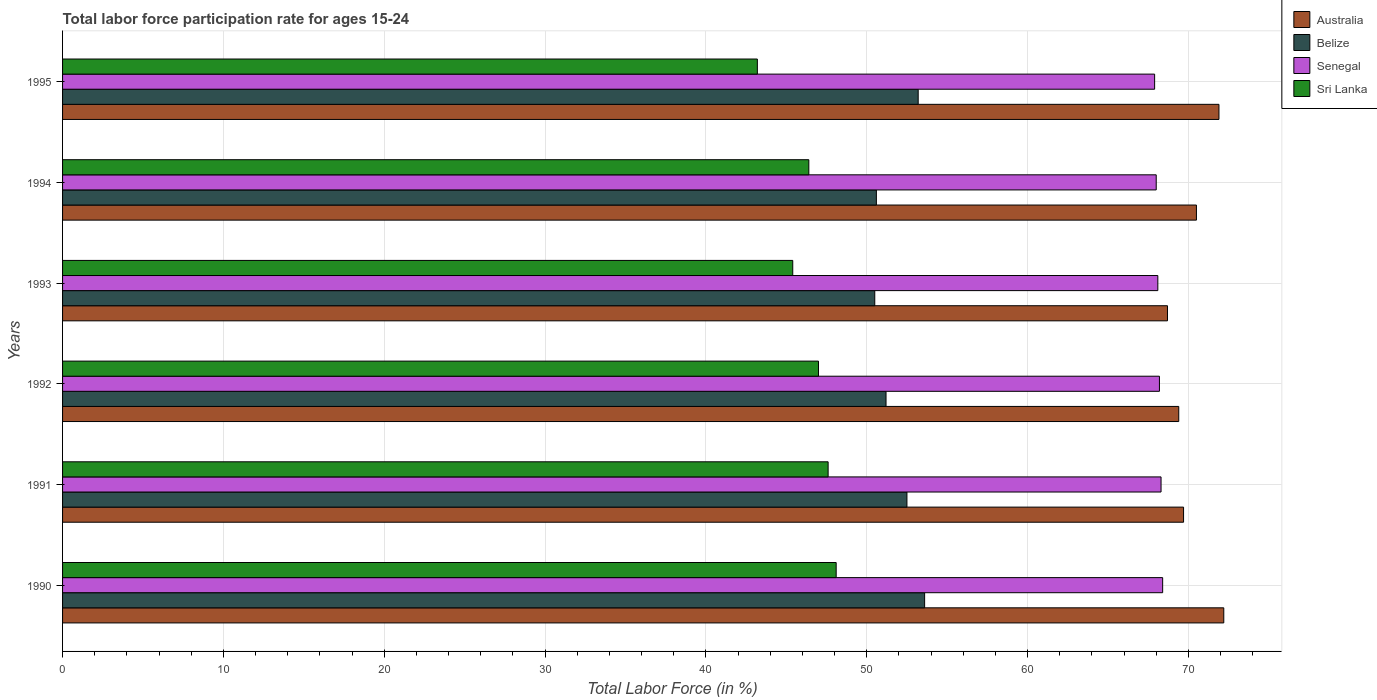How many different coloured bars are there?
Provide a succinct answer. 4. How many groups of bars are there?
Offer a terse response. 6. Are the number of bars per tick equal to the number of legend labels?
Offer a very short reply. Yes. Are the number of bars on each tick of the Y-axis equal?
Your answer should be very brief. Yes. How many bars are there on the 5th tick from the top?
Offer a very short reply. 4. How many bars are there on the 4th tick from the bottom?
Your answer should be very brief. 4. In how many cases, is the number of bars for a given year not equal to the number of legend labels?
Give a very brief answer. 0. What is the labor force participation rate in Sri Lanka in 1993?
Provide a short and direct response. 45.4. Across all years, what is the maximum labor force participation rate in Belize?
Provide a short and direct response. 53.6. Across all years, what is the minimum labor force participation rate in Belize?
Make the answer very short. 50.5. In which year was the labor force participation rate in Belize maximum?
Your answer should be compact. 1990. In which year was the labor force participation rate in Sri Lanka minimum?
Your response must be concise. 1995. What is the total labor force participation rate in Senegal in the graph?
Keep it short and to the point. 408.9. What is the difference between the labor force participation rate in Belize in 1994 and that in 1995?
Provide a succinct answer. -2.6. What is the difference between the labor force participation rate in Sri Lanka in 1992 and the labor force participation rate in Senegal in 1995?
Your response must be concise. -20.9. What is the average labor force participation rate in Sri Lanka per year?
Ensure brevity in your answer.  46.28. In the year 1993, what is the difference between the labor force participation rate in Australia and labor force participation rate in Belize?
Ensure brevity in your answer.  18.2. What is the ratio of the labor force participation rate in Australia in 1994 to that in 1995?
Offer a very short reply. 0.98. Is the difference between the labor force participation rate in Australia in 1990 and 1993 greater than the difference between the labor force participation rate in Belize in 1990 and 1993?
Your answer should be very brief. Yes. What is the difference between the highest and the second highest labor force participation rate in Belize?
Ensure brevity in your answer.  0.4. What is the difference between the highest and the lowest labor force participation rate in Belize?
Your answer should be very brief. 3.1. Is the sum of the labor force participation rate in Australia in 1990 and 1995 greater than the maximum labor force participation rate in Belize across all years?
Make the answer very short. Yes. Is it the case that in every year, the sum of the labor force participation rate in Belize and labor force participation rate in Senegal is greater than the sum of labor force participation rate in Sri Lanka and labor force participation rate in Australia?
Provide a short and direct response. Yes. What does the 1st bar from the top in 1992 represents?
Make the answer very short. Sri Lanka. What does the 2nd bar from the bottom in 1994 represents?
Your answer should be very brief. Belize. Is it the case that in every year, the sum of the labor force participation rate in Belize and labor force participation rate in Senegal is greater than the labor force participation rate in Australia?
Keep it short and to the point. Yes. Does the graph contain any zero values?
Ensure brevity in your answer.  No. Does the graph contain grids?
Give a very brief answer. Yes. How many legend labels are there?
Offer a very short reply. 4. What is the title of the graph?
Offer a very short reply. Total labor force participation rate for ages 15-24. Does "Upper middle income" appear as one of the legend labels in the graph?
Make the answer very short. No. What is the Total Labor Force (in %) in Australia in 1990?
Your response must be concise. 72.2. What is the Total Labor Force (in %) of Belize in 1990?
Give a very brief answer. 53.6. What is the Total Labor Force (in %) in Senegal in 1990?
Ensure brevity in your answer.  68.4. What is the Total Labor Force (in %) of Sri Lanka in 1990?
Ensure brevity in your answer.  48.1. What is the Total Labor Force (in %) in Australia in 1991?
Your answer should be very brief. 69.7. What is the Total Labor Force (in %) in Belize in 1991?
Offer a very short reply. 52.5. What is the Total Labor Force (in %) of Senegal in 1991?
Offer a very short reply. 68.3. What is the Total Labor Force (in %) in Sri Lanka in 1991?
Make the answer very short. 47.6. What is the Total Labor Force (in %) of Australia in 1992?
Your answer should be very brief. 69.4. What is the Total Labor Force (in %) in Belize in 1992?
Your answer should be very brief. 51.2. What is the Total Labor Force (in %) in Senegal in 1992?
Give a very brief answer. 68.2. What is the Total Labor Force (in %) in Australia in 1993?
Your answer should be very brief. 68.7. What is the Total Labor Force (in %) in Belize in 1993?
Offer a terse response. 50.5. What is the Total Labor Force (in %) of Senegal in 1993?
Provide a succinct answer. 68.1. What is the Total Labor Force (in %) of Sri Lanka in 1993?
Provide a succinct answer. 45.4. What is the Total Labor Force (in %) of Australia in 1994?
Offer a terse response. 70.5. What is the Total Labor Force (in %) of Belize in 1994?
Offer a terse response. 50.6. What is the Total Labor Force (in %) of Senegal in 1994?
Your answer should be compact. 68. What is the Total Labor Force (in %) in Sri Lanka in 1994?
Make the answer very short. 46.4. What is the Total Labor Force (in %) of Australia in 1995?
Offer a terse response. 71.9. What is the Total Labor Force (in %) of Belize in 1995?
Provide a short and direct response. 53.2. What is the Total Labor Force (in %) in Senegal in 1995?
Offer a terse response. 67.9. What is the Total Labor Force (in %) in Sri Lanka in 1995?
Your answer should be compact. 43.2. Across all years, what is the maximum Total Labor Force (in %) in Australia?
Offer a terse response. 72.2. Across all years, what is the maximum Total Labor Force (in %) in Belize?
Offer a very short reply. 53.6. Across all years, what is the maximum Total Labor Force (in %) in Senegal?
Keep it short and to the point. 68.4. Across all years, what is the maximum Total Labor Force (in %) in Sri Lanka?
Offer a terse response. 48.1. Across all years, what is the minimum Total Labor Force (in %) in Australia?
Ensure brevity in your answer.  68.7. Across all years, what is the minimum Total Labor Force (in %) of Belize?
Provide a succinct answer. 50.5. Across all years, what is the minimum Total Labor Force (in %) in Senegal?
Offer a terse response. 67.9. Across all years, what is the minimum Total Labor Force (in %) of Sri Lanka?
Your answer should be compact. 43.2. What is the total Total Labor Force (in %) of Australia in the graph?
Provide a short and direct response. 422.4. What is the total Total Labor Force (in %) of Belize in the graph?
Offer a terse response. 311.6. What is the total Total Labor Force (in %) in Senegal in the graph?
Provide a short and direct response. 408.9. What is the total Total Labor Force (in %) of Sri Lanka in the graph?
Provide a short and direct response. 277.7. What is the difference between the Total Labor Force (in %) in Belize in 1990 and that in 1991?
Offer a very short reply. 1.1. What is the difference between the Total Labor Force (in %) in Senegal in 1990 and that in 1991?
Offer a terse response. 0.1. What is the difference between the Total Labor Force (in %) in Sri Lanka in 1990 and that in 1991?
Offer a very short reply. 0.5. What is the difference between the Total Labor Force (in %) in Australia in 1990 and that in 1992?
Your answer should be compact. 2.8. What is the difference between the Total Labor Force (in %) in Australia in 1990 and that in 1993?
Your answer should be very brief. 3.5. What is the difference between the Total Labor Force (in %) in Belize in 1990 and that in 1994?
Your answer should be very brief. 3. What is the difference between the Total Labor Force (in %) of Senegal in 1990 and that in 1995?
Offer a terse response. 0.5. What is the difference between the Total Labor Force (in %) of Australia in 1991 and that in 1992?
Your response must be concise. 0.3. What is the difference between the Total Labor Force (in %) of Belize in 1991 and that in 1992?
Offer a terse response. 1.3. What is the difference between the Total Labor Force (in %) in Senegal in 1991 and that in 1992?
Provide a short and direct response. 0.1. What is the difference between the Total Labor Force (in %) of Australia in 1991 and that in 1993?
Your answer should be very brief. 1. What is the difference between the Total Labor Force (in %) of Senegal in 1991 and that in 1993?
Your answer should be compact. 0.2. What is the difference between the Total Labor Force (in %) of Australia in 1991 and that in 1994?
Provide a succinct answer. -0.8. What is the difference between the Total Labor Force (in %) in Belize in 1991 and that in 1995?
Offer a very short reply. -0.7. What is the difference between the Total Labor Force (in %) of Sri Lanka in 1991 and that in 1995?
Provide a short and direct response. 4.4. What is the difference between the Total Labor Force (in %) in Belize in 1992 and that in 1993?
Offer a very short reply. 0.7. What is the difference between the Total Labor Force (in %) of Australia in 1992 and that in 1994?
Your answer should be compact. -1.1. What is the difference between the Total Labor Force (in %) in Senegal in 1992 and that in 1994?
Your answer should be compact. 0.2. What is the difference between the Total Labor Force (in %) in Belize in 1992 and that in 1995?
Your response must be concise. -2. What is the difference between the Total Labor Force (in %) of Sri Lanka in 1992 and that in 1995?
Make the answer very short. 3.8. What is the difference between the Total Labor Force (in %) of Belize in 1993 and that in 1994?
Offer a very short reply. -0.1. What is the difference between the Total Labor Force (in %) of Senegal in 1993 and that in 1994?
Make the answer very short. 0.1. What is the difference between the Total Labor Force (in %) in Sri Lanka in 1993 and that in 1994?
Keep it short and to the point. -1. What is the difference between the Total Labor Force (in %) of Belize in 1993 and that in 1995?
Keep it short and to the point. -2.7. What is the difference between the Total Labor Force (in %) of Senegal in 1993 and that in 1995?
Your answer should be compact. 0.2. What is the difference between the Total Labor Force (in %) of Australia in 1994 and that in 1995?
Offer a very short reply. -1.4. What is the difference between the Total Labor Force (in %) in Belize in 1994 and that in 1995?
Provide a succinct answer. -2.6. What is the difference between the Total Labor Force (in %) in Senegal in 1994 and that in 1995?
Your answer should be very brief. 0.1. What is the difference between the Total Labor Force (in %) of Sri Lanka in 1994 and that in 1995?
Your answer should be compact. 3.2. What is the difference between the Total Labor Force (in %) in Australia in 1990 and the Total Labor Force (in %) in Belize in 1991?
Offer a terse response. 19.7. What is the difference between the Total Labor Force (in %) of Australia in 1990 and the Total Labor Force (in %) of Senegal in 1991?
Your answer should be compact. 3.9. What is the difference between the Total Labor Force (in %) of Australia in 1990 and the Total Labor Force (in %) of Sri Lanka in 1991?
Give a very brief answer. 24.6. What is the difference between the Total Labor Force (in %) in Belize in 1990 and the Total Labor Force (in %) in Senegal in 1991?
Ensure brevity in your answer.  -14.7. What is the difference between the Total Labor Force (in %) of Belize in 1990 and the Total Labor Force (in %) of Sri Lanka in 1991?
Your answer should be very brief. 6. What is the difference between the Total Labor Force (in %) in Senegal in 1990 and the Total Labor Force (in %) in Sri Lanka in 1991?
Make the answer very short. 20.8. What is the difference between the Total Labor Force (in %) in Australia in 1990 and the Total Labor Force (in %) in Belize in 1992?
Provide a succinct answer. 21. What is the difference between the Total Labor Force (in %) in Australia in 1990 and the Total Labor Force (in %) in Senegal in 1992?
Keep it short and to the point. 4. What is the difference between the Total Labor Force (in %) in Australia in 1990 and the Total Labor Force (in %) in Sri Lanka in 1992?
Offer a very short reply. 25.2. What is the difference between the Total Labor Force (in %) in Belize in 1990 and the Total Labor Force (in %) in Senegal in 1992?
Your answer should be very brief. -14.6. What is the difference between the Total Labor Force (in %) in Belize in 1990 and the Total Labor Force (in %) in Sri Lanka in 1992?
Make the answer very short. 6.6. What is the difference between the Total Labor Force (in %) in Senegal in 1990 and the Total Labor Force (in %) in Sri Lanka in 1992?
Provide a short and direct response. 21.4. What is the difference between the Total Labor Force (in %) of Australia in 1990 and the Total Labor Force (in %) of Belize in 1993?
Your answer should be compact. 21.7. What is the difference between the Total Labor Force (in %) in Australia in 1990 and the Total Labor Force (in %) in Sri Lanka in 1993?
Your answer should be compact. 26.8. What is the difference between the Total Labor Force (in %) of Belize in 1990 and the Total Labor Force (in %) of Senegal in 1993?
Your answer should be very brief. -14.5. What is the difference between the Total Labor Force (in %) in Australia in 1990 and the Total Labor Force (in %) in Belize in 1994?
Offer a very short reply. 21.6. What is the difference between the Total Labor Force (in %) in Australia in 1990 and the Total Labor Force (in %) in Sri Lanka in 1994?
Provide a succinct answer. 25.8. What is the difference between the Total Labor Force (in %) of Belize in 1990 and the Total Labor Force (in %) of Senegal in 1994?
Offer a very short reply. -14.4. What is the difference between the Total Labor Force (in %) in Senegal in 1990 and the Total Labor Force (in %) in Sri Lanka in 1994?
Your response must be concise. 22. What is the difference between the Total Labor Force (in %) of Belize in 1990 and the Total Labor Force (in %) of Senegal in 1995?
Provide a succinct answer. -14.3. What is the difference between the Total Labor Force (in %) of Belize in 1990 and the Total Labor Force (in %) of Sri Lanka in 1995?
Your answer should be compact. 10.4. What is the difference between the Total Labor Force (in %) in Senegal in 1990 and the Total Labor Force (in %) in Sri Lanka in 1995?
Give a very brief answer. 25.2. What is the difference between the Total Labor Force (in %) of Australia in 1991 and the Total Labor Force (in %) of Belize in 1992?
Ensure brevity in your answer.  18.5. What is the difference between the Total Labor Force (in %) of Australia in 1991 and the Total Labor Force (in %) of Senegal in 1992?
Give a very brief answer. 1.5. What is the difference between the Total Labor Force (in %) of Australia in 1991 and the Total Labor Force (in %) of Sri Lanka in 1992?
Ensure brevity in your answer.  22.7. What is the difference between the Total Labor Force (in %) of Belize in 1991 and the Total Labor Force (in %) of Senegal in 1992?
Provide a short and direct response. -15.7. What is the difference between the Total Labor Force (in %) in Belize in 1991 and the Total Labor Force (in %) in Sri Lanka in 1992?
Provide a short and direct response. 5.5. What is the difference between the Total Labor Force (in %) in Senegal in 1991 and the Total Labor Force (in %) in Sri Lanka in 1992?
Make the answer very short. 21.3. What is the difference between the Total Labor Force (in %) of Australia in 1991 and the Total Labor Force (in %) of Senegal in 1993?
Provide a succinct answer. 1.6. What is the difference between the Total Labor Force (in %) of Australia in 1991 and the Total Labor Force (in %) of Sri Lanka in 1993?
Your answer should be very brief. 24.3. What is the difference between the Total Labor Force (in %) in Belize in 1991 and the Total Labor Force (in %) in Senegal in 1993?
Offer a terse response. -15.6. What is the difference between the Total Labor Force (in %) in Belize in 1991 and the Total Labor Force (in %) in Sri Lanka in 1993?
Keep it short and to the point. 7.1. What is the difference between the Total Labor Force (in %) of Senegal in 1991 and the Total Labor Force (in %) of Sri Lanka in 1993?
Your answer should be compact. 22.9. What is the difference between the Total Labor Force (in %) of Australia in 1991 and the Total Labor Force (in %) of Belize in 1994?
Offer a terse response. 19.1. What is the difference between the Total Labor Force (in %) of Australia in 1991 and the Total Labor Force (in %) of Senegal in 1994?
Your answer should be compact. 1.7. What is the difference between the Total Labor Force (in %) of Australia in 1991 and the Total Labor Force (in %) of Sri Lanka in 1994?
Offer a terse response. 23.3. What is the difference between the Total Labor Force (in %) of Belize in 1991 and the Total Labor Force (in %) of Senegal in 1994?
Provide a succinct answer. -15.5. What is the difference between the Total Labor Force (in %) of Belize in 1991 and the Total Labor Force (in %) of Sri Lanka in 1994?
Offer a terse response. 6.1. What is the difference between the Total Labor Force (in %) in Senegal in 1991 and the Total Labor Force (in %) in Sri Lanka in 1994?
Offer a terse response. 21.9. What is the difference between the Total Labor Force (in %) of Australia in 1991 and the Total Labor Force (in %) of Sri Lanka in 1995?
Your answer should be compact. 26.5. What is the difference between the Total Labor Force (in %) of Belize in 1991 and the Total Labor Force (in %) of Senegal in 1995?
Your answer should be compact. -15.4. What is the difference between the Total Labor Force (in %) in Senegal in 1991 and the Total Labor Force (in %) in Sri Lanka in 1995?
Your answer should be compact. 25.1. What is the difference between the Total Labor Force (in %) of Australia in 1992 and the Total Labor Force (in %) of Senegal in 1993?
Make the answer very short. 1.3. What is the difference between the Total Labor Force (in %) in Australia in 1992 and the Total Labor Force (in %) in Sri Lanka in 1993?
Keep it short and to the point. 24. What is the difference between the Total Labor Force (in %) of Belize in 1992 and the Total Labor Force (in %) of Senegal in 1993?
Ensure brevity in your answer.  -16.9. What is the difference between the Total Labor Force (in %) of Belize in 1992 and the Total Labor Force (in %) of Sri Lanka in 1993?
Your answer should be compact. 5.8. What is the difference between the Total Labor Force (in %) in Senegal in 1992 and the Total Labor Force (in %) in Sri Lanka in 1993?
Ensure brevity in your answer.  22.8. What is the difference between the Total Labor Force (in %) of Australia in 1992 and the Total Labor Force (in %) of Sri Lanka in 1994?
Provide a succinct answer. 23. What is the difference between the Total Labor Force (in %) in Belize in 1992 and the Total Labor Force (in %) in Senegal in 1994?
Give a very brief answer. -16.8. What is the difference between the Total Labor Force (in %) in Belize in 1992 and the Total Labor Force (in %) in Sri Lanka in 1994?
Make the answer very short. 4.8. What is the difference between the Total Labor Force (in %) in Senegal in 1992 and the Total Labor Force (in %) in Sri Lanka in 1994?
Offer a terse response. 21.8. What is the difference between the Total Labor Force (in %) of Australia in 1992 and the Total Labor Force (in %) of Sri Lanka in 1995?
Your response must be concise. 26.2. What is the difference between the Total Labor Force (in %) in Belize in 1992 and the Total Labor Force (in %) in Senegal in 1995?
Your answer should be very brief. -16.7. What is the difference between the Total Labor Force (in %) in Senegal in 1992 and the Total Labor Force (in %) in Sri Lanka in 1995?
Your answer should be very brief. 25. What is the difference between the Total Labor Force (in %) of Australia in 1993 and the Total Labor Force (in %) of Belize in 1994?
Your response must be concise. 18.1. What is the difference between the Total Labor Force (in %) of Australia in 1993 and the Total Labor Force (in %) of Sri Lanka in 1994?
Provide a short and direct response. 22.3. What is the difference between the Total Labor Force (in %) in Belize in 1993 and the Total Labor Force (in %) in Senegal in 1994?
Your answer should be very brief. -17.5. What is the difference between the Total Labor Force (in %) in Senegal in 1993 and the Total Labor Force (in %) in Sri Lanka in 1994?
Your answer should be compact. 21.7. What is the difference between the Total Labor Force (in %) of Australia in 1993 and the Total Labor Force (in %) of Belize in 1995?
Make the answer very short. 15.5. What is the difference between the Total Labor Force (in %) of Australia in 1993 and the Total Labor Force (in %) of Sri Lanka in 1995?
Your answer should be very brief. 25.5. What is the difference between the Total Labor Force (in %) in Belize in 1993 and the Total Labor Force (in %) in Senegal in 1995?
Your answer should be compact. -17.4. What is the difference between the Total Labor Force (in %) in Belize in 1993 and the Total Labor Force (in %) in Sri Lanka in 1995?
Your response must be concise. 7.3. What is the difference between the Total Labor Force (in %) in Senegal in 1993 and the Total Labor Force (in %) in Sri Lanka in 1995?
Make the answer very short. 24.9. What is the difference between the Total Labor Force (in %) in Australia in 1994 and the Total Labor Force (in %) in Belize in 1995?
Give a very brief answer. 17.3. What is the difference between the Total Labor Force (in %) in Australia in 1994 and the Total Labor Force (in %) in Sri Lanka in 1995?
Ensure brevity in your answer.  27.3. What is the difference between the Total Labor Force (in %) in Belize in 1994 and the Total Labor Force (in %) in Senegal in 1995?
Your answer should be compact. -17.3. What is the difference between the Total Labor Force (in %) of Senegal in 1994 and the Total Labor Force (in %) of Sri Lanka in 1995?
Your answer should be very brief. 24.8. What is the average Total Labor Force (in %) in Australia per year?
Your answer should be compact. 70.4. What is the average Total Labor Force (in %) in Belize per year?
Your answer should be compact. 51.93. What is the average Total Labor Force (in %) of Senegal per year?
Offer a very short reply. 68.15. What is the average Total Labor Force (in %) in Sri Lanka per year?
Offer a very short reply. 46.28. In the year 1990, what is the difference between the Total Labor Force (in %) in Australia and Total Labor Force (in %) in Belize?
Your answer should be compact. 18.6. In the year 1990, what is the difference between the Total Labor Force (in %) of Australia and Total Labor Force (in %) of Sri Lanka?
Your response must be concise. 24.1. In the year 1990, what is the difference between the Total Labor Force (in %) of Belize and Total Labor Force (in %) of Senegal?
Your response must be concise. -14.8. In the year 1990, what is the difference between the Total Labor Force (in %) in Senegal and Total Labor Force (in %) in Sri Lanka?
Offer a terse response. 20.3. In the year 1991, what is the difference between the Total Labor Force (in %) of Australia and Total Labor Force (in %) of Sri Lanka?
Make the answer very short. 22.1. In the year 1991, what is the difference between the Total Labor Force (in %) in Belize and Total Labor Force (in %) in Senegal?
Your answer should be very brief. -15.8. In the year 1991, what is the difference between the Total Labor Force (in %) in Senegal and Total Labor Force (in %) in Sri Lanka?
Provide a short and direct response. 20.7. In the year 1992, what is the difference between the Total Labor Force (in %) in Australia and Total Labor Force (in %) in Belize?
Your response must be concise. 18.2. In the year 1992, what is the difference between the Total Labor Force (in %) of Australia and Total Labor Force (in %) of Sri Lanka?
Give a very brief answer. 22.4. In the year 1992, what is the difference between the Total Labor Force (in %) of Belize and Total Labor Force (in %) of Senegal?
Give a very brief answer. -17. In the year 1992, what is the difference between the Total Labor Force (in %) in Belize and Total Labor Force (in %) in Sri Lanka?
Make the answer very short. 4.2. In the year 1992, what is the difference between the Total Labor Force (in %) of Senegal and Total Labor Force (in %) of Sri Lanka?
Your answer should be very brief. 21.2. In the year 1993, what is the difference between the Total Labor Force (in %) in Australia and Total Labor Force (in %) in Senegal?
Keep it short and to the point. 0.6. In the year 1993, what is the difference between the Total Labor Force (in %) in Australia and Total Labor Force (in %) in Sri Lanka?
Offer a very short reply. 23.3. In the year 1993, what is the difference between the Total Labor Force (in %) in Belize and Total Labor Force (in %) in Senegal?
Keep it short and to the point. -17.6. In the year 1993, what is the difference between the Total Labor Force (in %) of Senegal and Total Labor Force (in %) of Sri Lanka?
Offer a very short reply. 22.7. In the year 1994, what is the difference between the Total Labor Force (in %) of Australia and Total Labor Force (in %) of Belize?
Your answer should be compact. 19.9. In the year 1994, what is the difference between the Total Labor Force (in %) in Australia and Total Labor Force (in %) in Sri Lanka?
Provide a short and direct response. 24.1. In the year 1994, what is the difference between the Total Labor Force (in %) in Belize and Total Labor Force (in %) in Senegal?
Provide a succinct answer. -17.4. In the year 1994, what is the difference between the Total Labor Force (in %) of Belize and Total Labor Force (in %) of Sri Lanka?
Offer a very short reply. 4.2. In the year 1994, what is the difference between the Total Labor Force (in %) in Senegal and Total Labor Force (in %) in Sri Lanka?
Make the answer very short. 21.6. In the year 1995, what is the difference between the Total Labor Force (in %) of Australia and Total Labor Force (in %) of Belize?
Your answer should be very brief. 18.7. In the year 1995, what is the difference between the Total Labor Force (in %) in Australia and Total Labor Force (in %) in Senegal?
Offer a terse response. 4. In the year 1995, what is the difference between the Total Labor Force (in %) in Australia and Total Labor Force (in %) in Sri Lanka?
Offer a terse response. 28.7. In the year 1995, what is the difference between the Total Labor Force (in %) in Belize and Total Labor Force (in %) in Senegal?
Ensure brevity in your answer.  -14.7. In the year 1995, what is the difference between the Total Labor Force (in %) of Belize and Total Labor Force (in %) of Sri Lanka?
Offer a very short reply. 10. In the year 1995, what is the difference between the Total Labor Force (in %) in Senegal and Total Labor Force (in %) in Sri Lanka?
Make the answer very short. 24.7. What is the ratio of the Total Labor Force (in %) of Australia in 1990 to that in 1991?
Your response must be concise. 1.04. What is the ratio of the Total Labor Force (in %) in Belize in 1990 to that in 1991?
Your answer should be very brief. 1.02. What is the ratio of the Total Labor Force (in %) of Senegal in 1990 to that in 1991?
Provide a short and direct response. 1. What is the ratio of the Total Labor Force (in %) of Sri Lanka in 1990 to that in 1991?
Offer a terse response. 1.01. What is the ratio of the Total Labor Force (in %) of Australia in 1990 to that in 1992?
Your response must be concise. 1.04. What is the ratio of the Total Labor Force (in %) of Belize in 1990 to that in 1992?
Give a very brief answer. 1.05. What is the ratio of the Total Labor Force (in %) of Sri Lanka in 1990 to that in 1992?
Make the answer very short. 1.02. What is the ratio of the Total Labor Force (in %) in Australia in 1990 to that in 1993?
Your response must be concise. 1.05. What is the ratio of the Total Labor Force (in %) in Belize in 1990 to that in 1993?
Offer a very short reply. 1.06. What is the ratio of the Total Labor Force (in %) of Sri Lanka in 1990 to that in 1993?
Your answer should be very brief. 1.06. What is the ratio of the Total Labor Force (in %) of Australia in 1990 to that in 1994?
Provide a short and direct response. 1.02. What is the ratio of the Total Labor Force (in %) in Belize in 1990 to that in 1994?
Offer a very short reply. 1.06. What is the ratio of the Total Labor Force (in %) of Senegal in 1990 to that in 1994?
Give a very brief answer. 1.01. What is the ratio of the Total Labor Force (in %) of Sri Lanka in 1990 to that in 1994?
Keep it short and to the point. 1.04. What is the ratio of the Total Labor Force (in %) in Australia in 1990 to that in 1995?
Keep it short and to the point. 1. What is the ratio of the Total Labor Force (in %) in Belize in 1990 to that in 1995?
Offer a terse response. 1.01. What is the ratio of the Total Labor Force (in %) in Senegal in 1990 to that in 1995?
Make the answer very short. 1.01. What is the ratio of the Total Labor Force (in %) in Sri Lanka in 1990 to that in 1995?
Keep it short and to the point. 1.11. What is the ratio of the Total Labor Force (in %) in Australia in 1991 to that in 1992?
Provide a short and direct response. 1. What is the ratio of the Total Labor Force (in %) of Belize in 1991 to that in 1992?
Offer a very short reply. 1.03. What is the ratio of the Total Labor Force (in %) of Senegal in 1991 to that in 1992?
Make the answer very short. 1. What is the ratio of the Total Labor Force (in %) of Sri Lanka in 1991 to that in 1992?
Offer a very short reply. 1.01. What is the ratio of the Total Labor Force (in %) of Australia in 1991 to that in 1993?
Your response must be concise. 1.01. What is the ratio of the Total Labor Force (in %) in Belize in 1991 to that in 1993?
Keep it short and to the point. 1.04. What is the ratio of the Total Labor Force (in %) in Senegal in 1991 to that in 1993?
Ensure brevity in your answer.  1. What is the ratio of the Total Labor Force (in %) of Sri Lanka in 1991 to that in 1993?
Offer a terse response. 1.05. What is the ratio of the Total Labor Force (in %) of Australia in 1991 to that in 1994?
Your answer should be compact. 0.99. What is the ratio of the Total Labor Force (in %) of Belize in 1991 to that in 1994?
Provide a succinct answer. 1.04. What is the ratio of the Total Labor Force (in %) in Sri Lanka in 1991 to that in 1994?
Keep it short and to the point. 1.03. What is the ratio of the Total Labor Force (in %) in Australia in 1991 to that in 1995?
Offer a very short reply. 0.97. What is the ratio of the Total Labor Force (in %) in Belize in 1991 to that in 1995?
Your answer should be compact. 0.99. What is the ratio of the Total Labor Force (in %) of Senegal in 1991 to that in 1995?
Offer a very short reply. 1.01. What is the ratio of the Total Labor Force (in %) in Sri Lanka in 1991 to that in 1995?
Your answer should be very brief. 1.1. What is the ratio of the Total Labor Force (in %) of Australia in 1992 to that in 1993?
Provide a short and direct response. 1.01. What is the ratio of the Total Labor Force (in %) of Belize in 1992 to that in 1993?
Keep it short and to the point. 1.01. What is the ratio of the Total Labor Force (in %) of Senegal in 1992 to that in 1993?
Make the answer very short. 1. What is the ratio of the Total Labor Force (in %) in Sri Lanka in 1992 to that in 1993?
Your answer should be very brief. 1.04. What is the ratio of the Total Labor Force (in %) of Australia in 1992 to that in 1994?
Provide a short and direct response. 0.98. What is the ratio of the Total Labor Force (in %) in Belize in 1992 to that in 1994?
Ensure brevity in your answer.  1.01. What is the ratio of the Total Labor Force (in %) in Senegal in 1992 to that in 1994?
Give a very brief answer. 1. What is the ratio of the Total Labor Force (in %) in Sri Lanka in 1992 to that in 1994?
Your answer should be very brief. 1.01. What is the ratio of the Total Labor Force (in %) of Australia in 1992 to that in 1995?
Keep it short and to the point. 0.97. What is the ratio of the Total Labor Force (in %) of Belize in 1992 to that in 1995?
Make the answer very short. 0.96. What is the ratio of the Total Labor Force (in %) of Senegal in 1992 to that in 1995?
Offer a very short reply. 1. What is the ratio of the Total Labor Force (in %) in Sri Lanka in 1992 to that in 1995?
Keep it short and to the point. 1.09. What is the ratio of the Total Labor Force (in %) in Australia in 1993 to that in 1994?
Ensure brevity in your answer.  0.97. What is the ratio of the Total Labor Force (in %) in Belize in 1993 to that in 1994?
Your answer should be very brief. 1. What is the ratio of the Total Labor Force (in %) in Sri Lanka in 1993 to that in 1994?
Provide a succinct answer. 0.98. What is the ratio of the Total Labor Force (in %) of Australia in 1993 to that in 1995?
Keep it short and to the point. 0.96. What is the ratio of the Total Labor Force (in %) of Belize in 1993 to that in 1995?
Offer a very short reply. 0.95. What is the ratio of the Total Labor Force (in %) of Sri Lanka in 1993 to that in 1995?
Offer a terse response. 1.05. What is the ratio of the Total Labor Force (in %) in Australia in 1994 to that in 1995?
Make the answer very short. 0.98. What is the ratio of the Total Labor Force (in %) of Belize in 1994 to that in 1995?
Make the answer very short. 0.95. What is the ratio of the Total Labor Force (in %) in Sri Lanka in 1994 to that in 1995?
Ensure brevity in your answer.  1.07. What is the difference between the highest and the lowest Total Labor Force (in %) of Australia?
Give a very brief answer. 3.5. What is the difference between the highest and the lowest Total Labor Force (in %) in Belize?
Your answer should be very brief. 3.1. What is the difference between the highest and the lowest Total Labor Force (in %) of Senegal?
Provide a short and direct response. 0.5. 